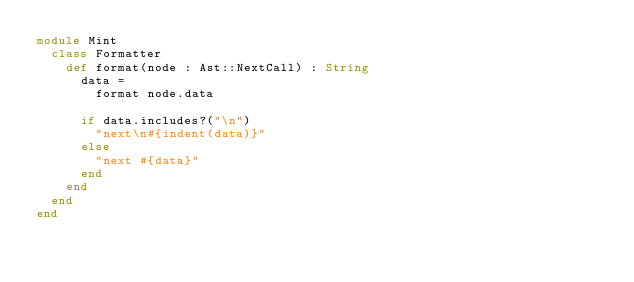<code> <loc_0><loc_0><loc_500><loc_500><_Crystal_>module Mint
  class Formatter
    def format(node : Ast::NextCall) : String
      data =
        format node.data

      if data.includes?("\n")
        "next\n#{indent(data)}"
      else
        "next #{data}"
      end
    end
  end
end
</code> 